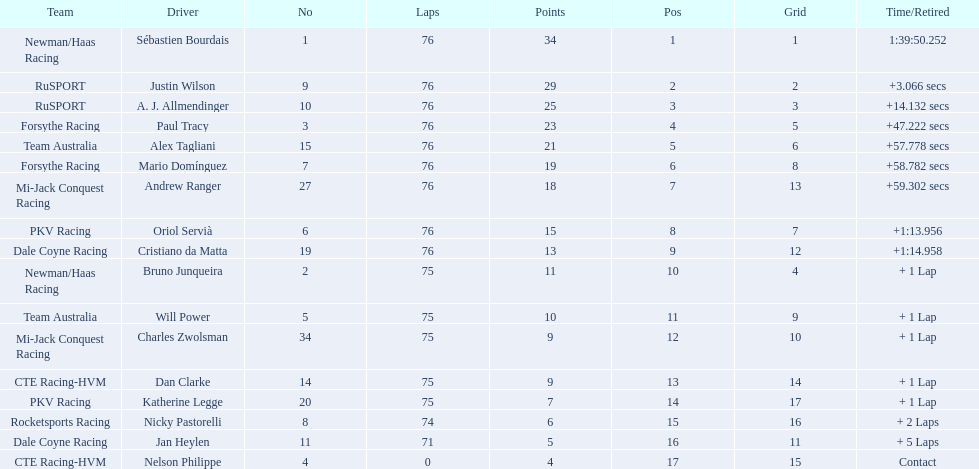What was alex taglini's final score in the tecate grand prix? 21. What was paul tracy's final score in the tecate grand prix? 23. Which driver finished first? Paul Tracy. 